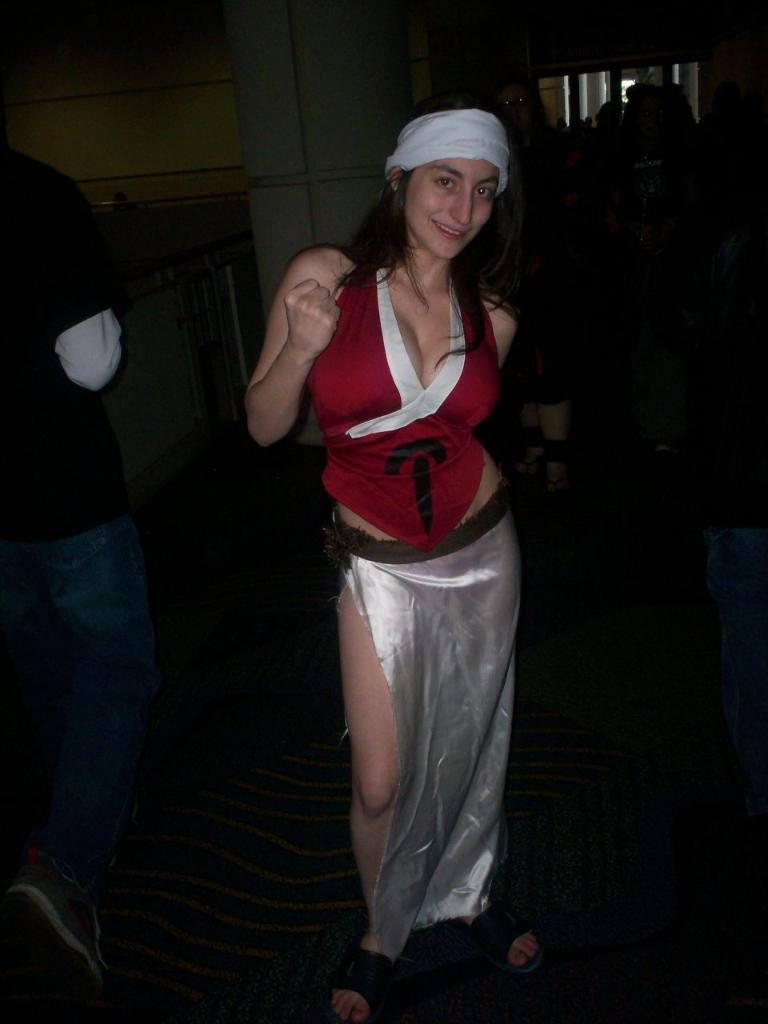What are the people in the image doing? The people in the image are standing on the floor. Can you describe the action of one of the people in the image? There is a person walking on the left side of the image. What can be seen in the background of the image? There is a pillar and a wall in the background of the image. What type of pencil is being used by the person walking in the image? There is no pencil present in the image; the person walking is not using any writing instrument. 